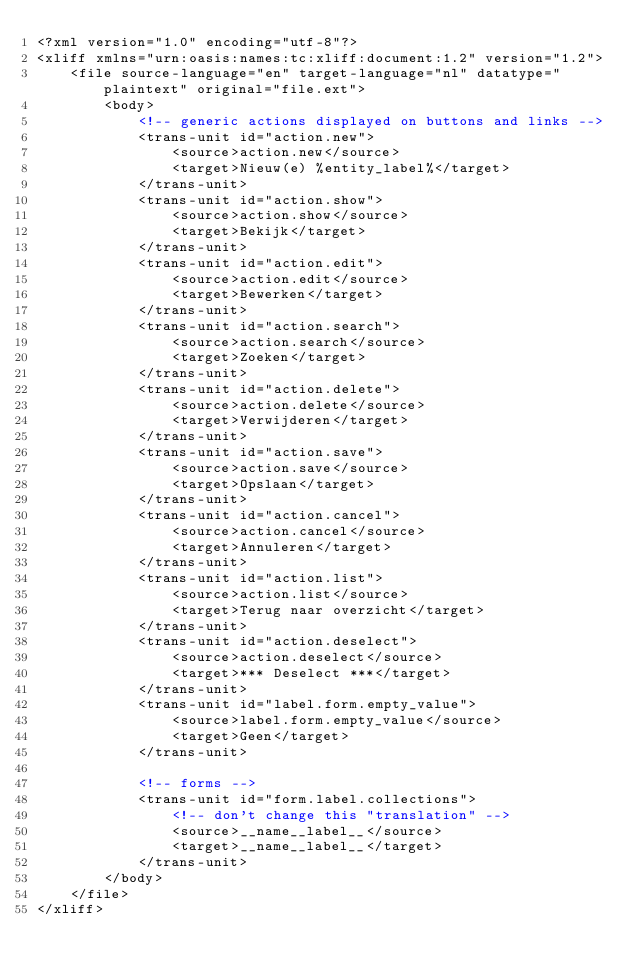Convert code to text. <code><loc_0><loc_0><loc_500><loc_500><_XML_><?xml version="1.0" encoding="utf-8"?>
<xliff xmlns="urn:oasis:names:tc:xliff:document:1.2" version="1.2">
    <file source-language="en" target-language="nl" datatype="plaintext" original="file.ext">
        <body>
            <!-- generic actions displayed on buttons and links -->
            <trans-unit id="action.new">
                <source>action.new</source>
                <target>Nieuw(e) %entity_label%</target>
            </trans-unit>
            <trans-unit id="action.show">
                <source>action.show</source>
                <target>Bekijk</target>
            </trans-unit>
            <trans-unit id="action.edit">
                <source>action.edit</source>
                <target>Bewerken</target>
            </trans-unit>
            <trans-unit id="action.search">
                <source>action.search</source>
                <target>Zoeken</target>
            </trans-unit>
            <trans-unit id="action.delete">
                <source>action.delete</source>
                <target>Verwijderen</target>
            </trans-unit>
            <trans-unit id="action.save">
                <source>action.save</source>
                <target>Opslaan</target>
            </trans-unit>
            <trans-unit id="action.cancel">
                <source>action.cancel</source>
                <target>Annuleren</target>
            </trans-unit>
            <trans-unit id="action.list">
                <source>action.list</source>
                <target>Terug naar overzicht</target>
            </trans-unit>
            <trans-unit id="action.deselect">
                <source>action.deselect</source>
                <target>*** Deselect ***</target>
            </trans-unit>
            <trans-unit id="label.form.empty_value">
                <source>label.form.empty_value</source>
                <target>Geen</target>
            </trans-unit>

            <!-- forms -->
            <trans-unit id="form.label.collections">
                <!-- don't change this "translation" -->
                <source>__name__label__</source>
                <target>__name__label__</target>
            </trans-unit>
        </body>
    </file>
</xliff>
</code> 